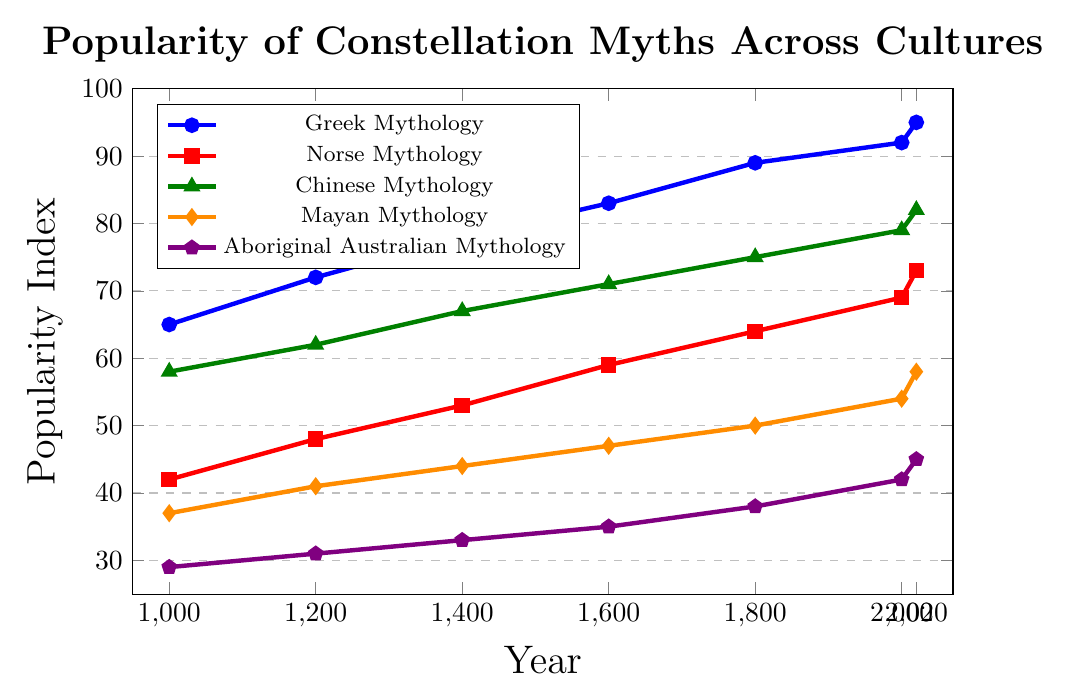Which mythology has the highest popularity in 2020? Look for the data point at 2020 and identify which mythology has the highest value. Greek Mythology has the highest value at 95.
Answer: Greek Mythology How did the popularity of Chinese Mythology change from 1400 to 1800? Note the values for Chinese Mythology at 1400 and 1800, which are 67 and 75, respectively. The change is 75 - 67 = 8.
Answer: Increased by 8 Which mythology has the lowest popularity in 1600? Compare the values for all mythologies in 1600. Aboriginal Australian Mythology has the lowest value at 35.
Answer: Aboriginal Australian Mythology What is the average popularity of Mayan Mythology across all years shown? Add up all the popularity values for Mayan Mythology and divide by the number of data points (7). (37 + 41 + 44 + 47 + 50 + 54 + 58) / 7 = 47.29.
Answer: 47.29 What is the difference in popularity between Greek and Norse Mythology in the year 2000? Subtract the popularity value of Norse Mythology from Greek Mythology in 2000. 92 - 69 = 23.
Answer: 23 Which mythology shows the most consistent increase across the timeline? Observe the trend lines for consistency in the increasing pattern. Greek Mythology shows the most consistent increase from 65 to 95 across the timeline.
Answer: Greek Mythology What is the overall trend of Aboriginal Australian Mythology's popularity from 1000 to 2020? The values for Aboriginal Australian Mythology increase steadily from 29 to 45 from 1000 to 2020.
Answer: Increasing How many years did it take for Norse Mythology to increase from 42 to 69 in popularity? Identify the years corresponding to the values 42 (1000) and 69 (2000) for Norse Mythology. The difference is 2000 - 1000 = 1000 years.
Answer: 1000 years Which two mythologies have the closest popularity values in 2020? Compare the values at 2020 and find the smallest difference: Norse Mythology (73) and Chinese Mythology (82) have a difference of 9.
Answer: Norse Mythology and Chinese Mythology In which period did Mayan Mythology see the highest absolute increase in popularity? Calculate the difference in popularity between successive periods for Mayan Mythology and identify the highest value: (54 - 50) = 4 increase from 1800 to 2000 is the highest.
Answer: 1800 to 2000 